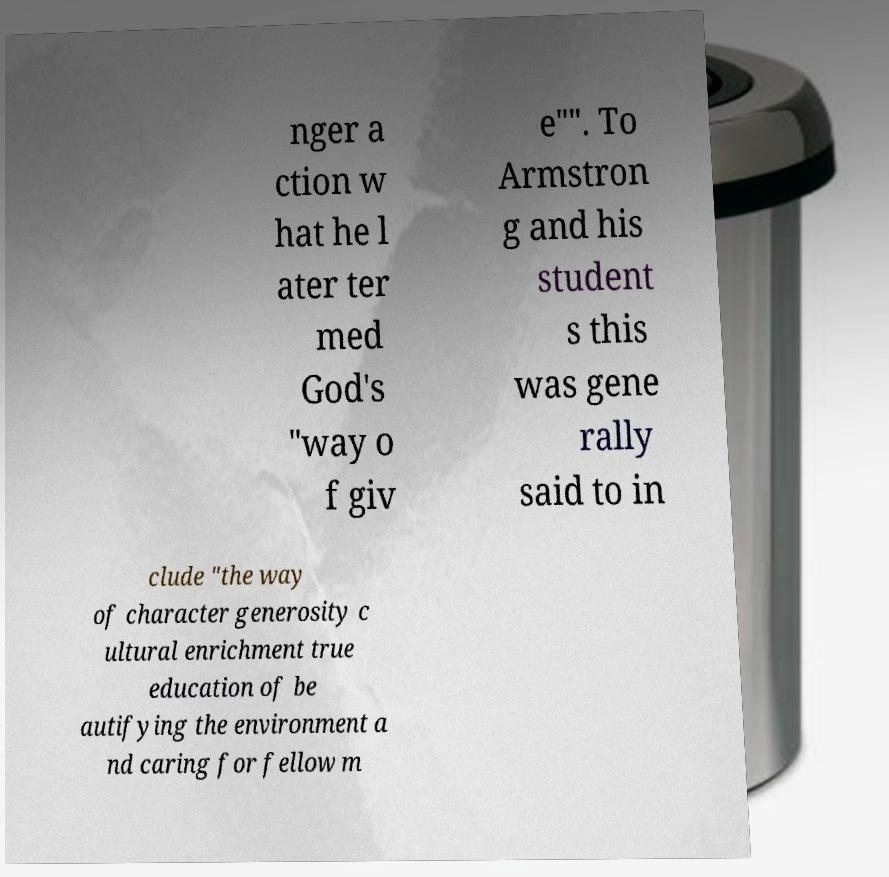Can you read and provide the text displayed in the image?This photo seems to have some interesting text. Can you extract and type it out for me? nger a ction w hat he l ater ter med God's "way o f giv e"". To Armstron g and his student s this was gene rally said to in clude "the way of character generosity c ultural enrichment true education of be autifying the environment a nd caring for fellow m 